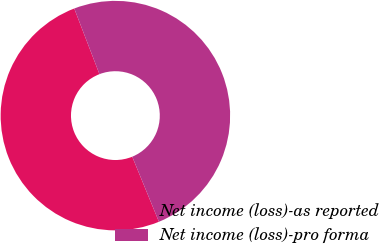<chart> <loc_0><loc_0><loc_500><loc_500><pie_chart><fcel>Net income (loss)-as reported<fcel>Net income (loss)-pro forma<nl><fcel>50.36%<fcel>49.64%<nl></chart> 